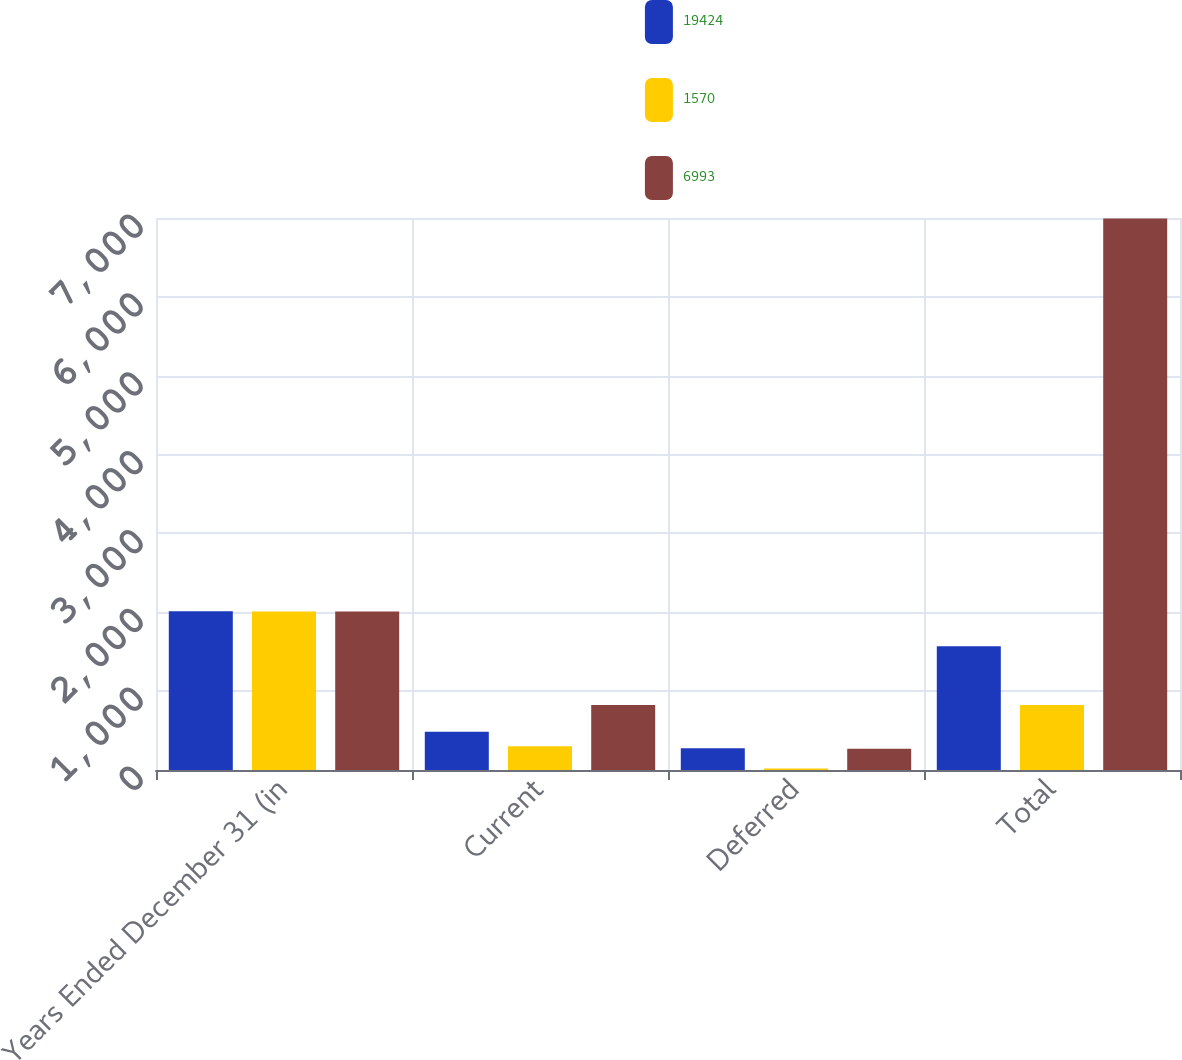Convert chart. <chart><loc_0><loc_0><loc_500><loc_500><stacked_bar_chart><ecel><fcel>Years Ended December 31 (in<fcel>Current<fcel>Deferred<fcel>Total<nl><fcel>19424<fcel>2012<fcel>484<fcel>275<fcel>1570<nl><fcel>1570<fcel>2011<fcel>302<fcel>20<fcel>823<nl><fcel>6993<fcel>2010<fcel>823<fcel>270<fcel>6993<nl></chart> 